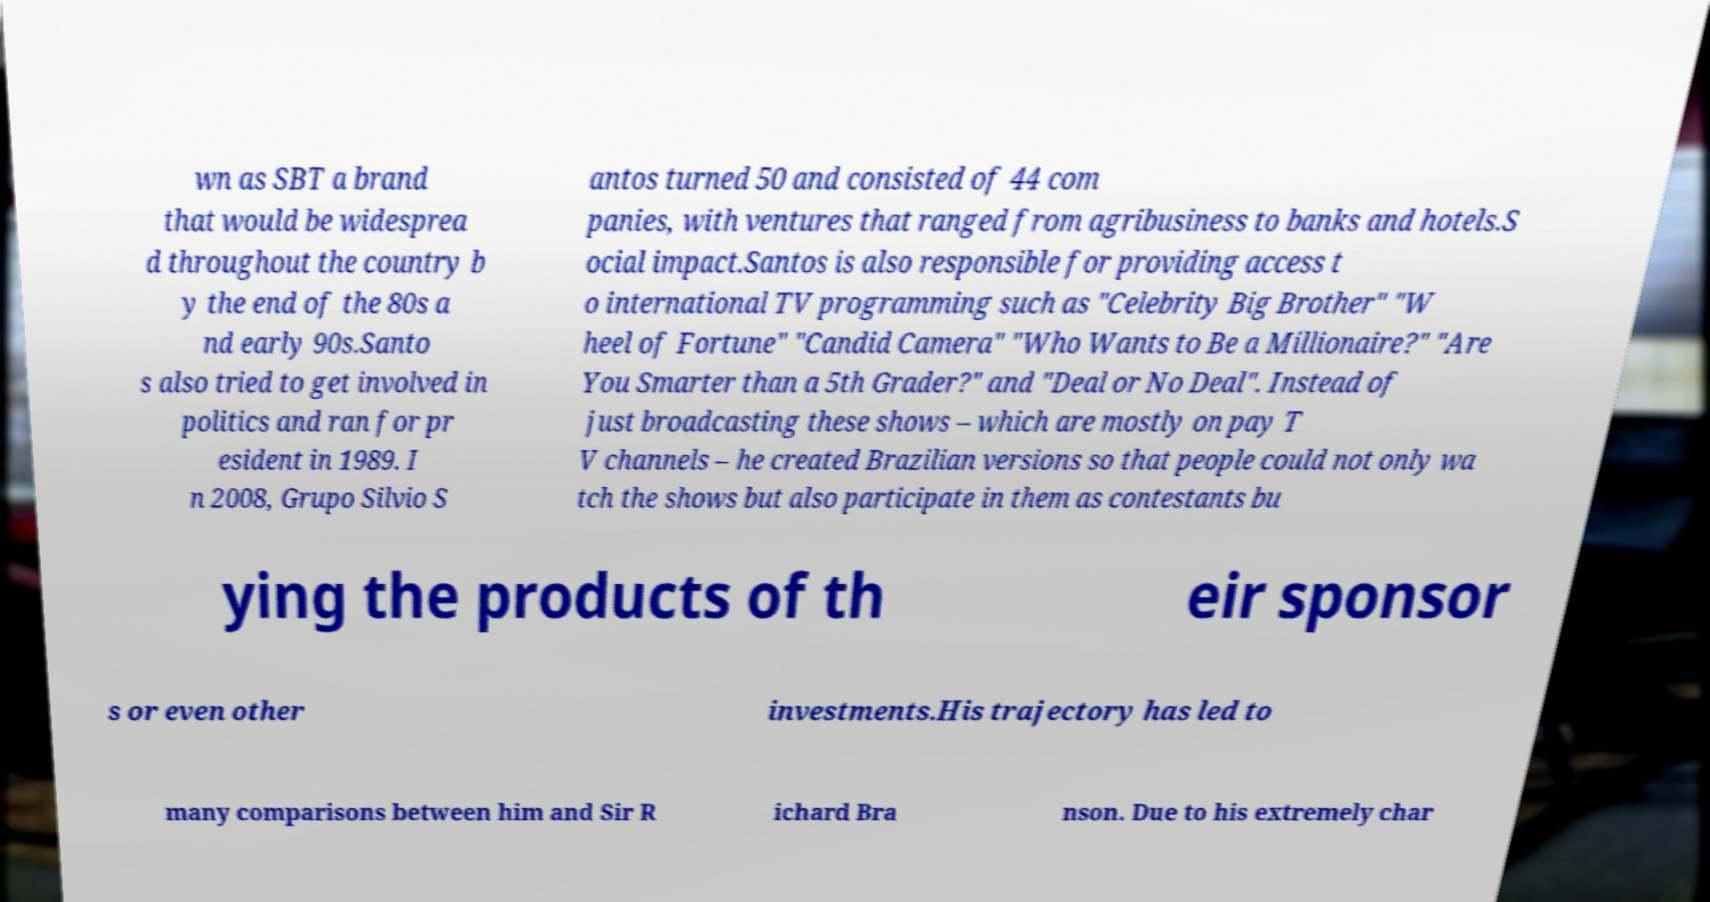What messages or text are displayed in this image? I need them in a readable, typed format. wn as SBT a brand that would be widesprea d throughout the country b y the end of the 80s a nd early 90s.Santo s also tried to get involved in politics and ran for pr esident in 1989. I n 2008, Grupo Silvio S antos turned 50 and consisted of 44 com panies, with ventures that ranged from agribusiness to banks and hotels.S ocial impact.Santos is also responsible for providing access t o international TV programming such as "Celebrity Big Brother" "W heel of Fortune" "Candid Camera" "Who Wants to Be a Millionaire?" "Are You Smarter than a 5th Grader?" and "Deal or No Deal". Instead of just broadcasting these shows – which are mostly on pay T V channels – he created Brazilian versions so that people could not only wa tch the shows but also participate in them as contestants bu ying the products of th eir sponsor s or even other investments.His trajectory has led to many comparisons between him and Sir R ichard Bra nson. Due to his extremely char 